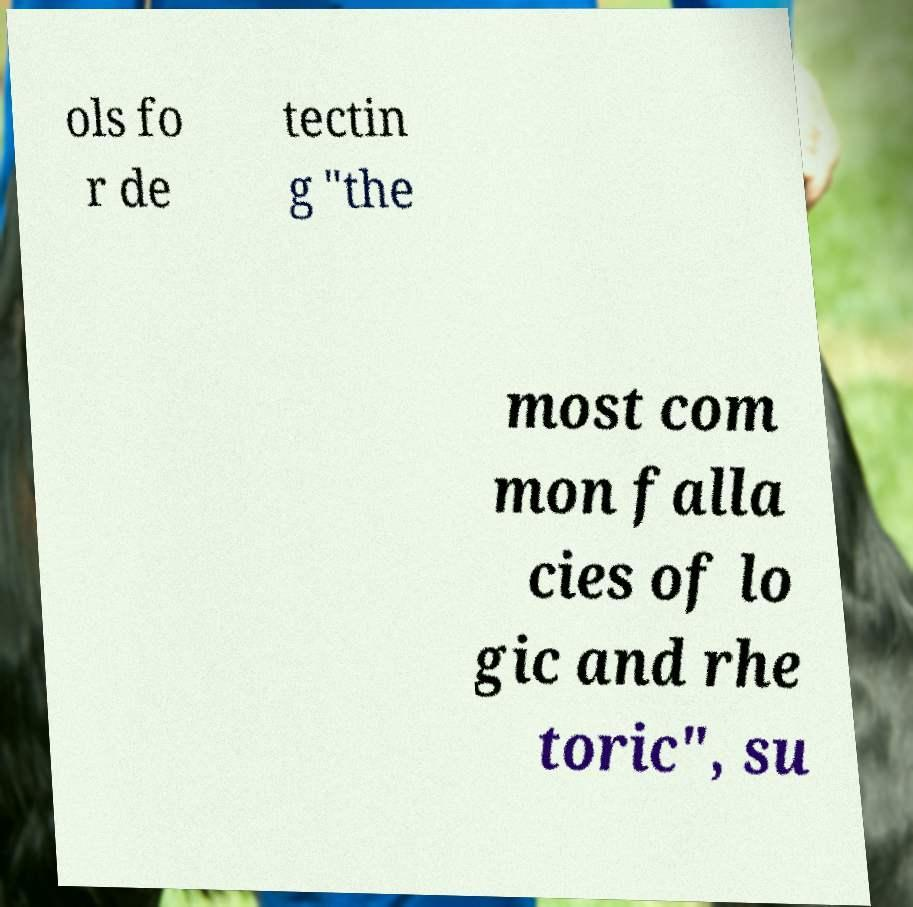For documentation purposes, I need the text within this image transcribed. Could you provide that? ols fo r de tectin g "the most com mon falla cies of lo gic and rhe toric", su 